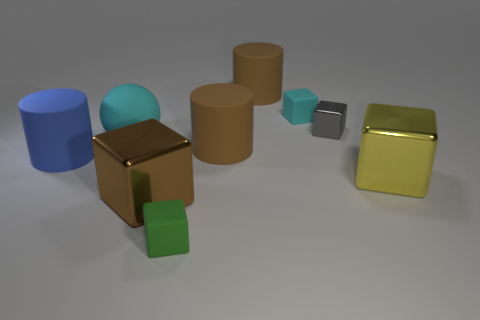Subtract all gray cubes. How many cubes are left? 4 Subtract all green blocks. How many blocks are left? 4 Subtract 2 cubes. How many cubes are left? 3 Subtract all blue cubes. Subtract all red balls. How many cubes are left? 5 Add 1 big brown matte things. How many objects exist? 10 Subtract all cylinders. How many objects are left? 6 Subtract 0 green balls. How many objects are left? 9 Subtract all big brown metal cubes. Subtract all red shiny blocks. How many objects are left? 8 Add 6 metal cubes. How many metal cubes are left? 9 Add 5 tiny cyan cubes. How many tiny cyan cubes exist? 6 